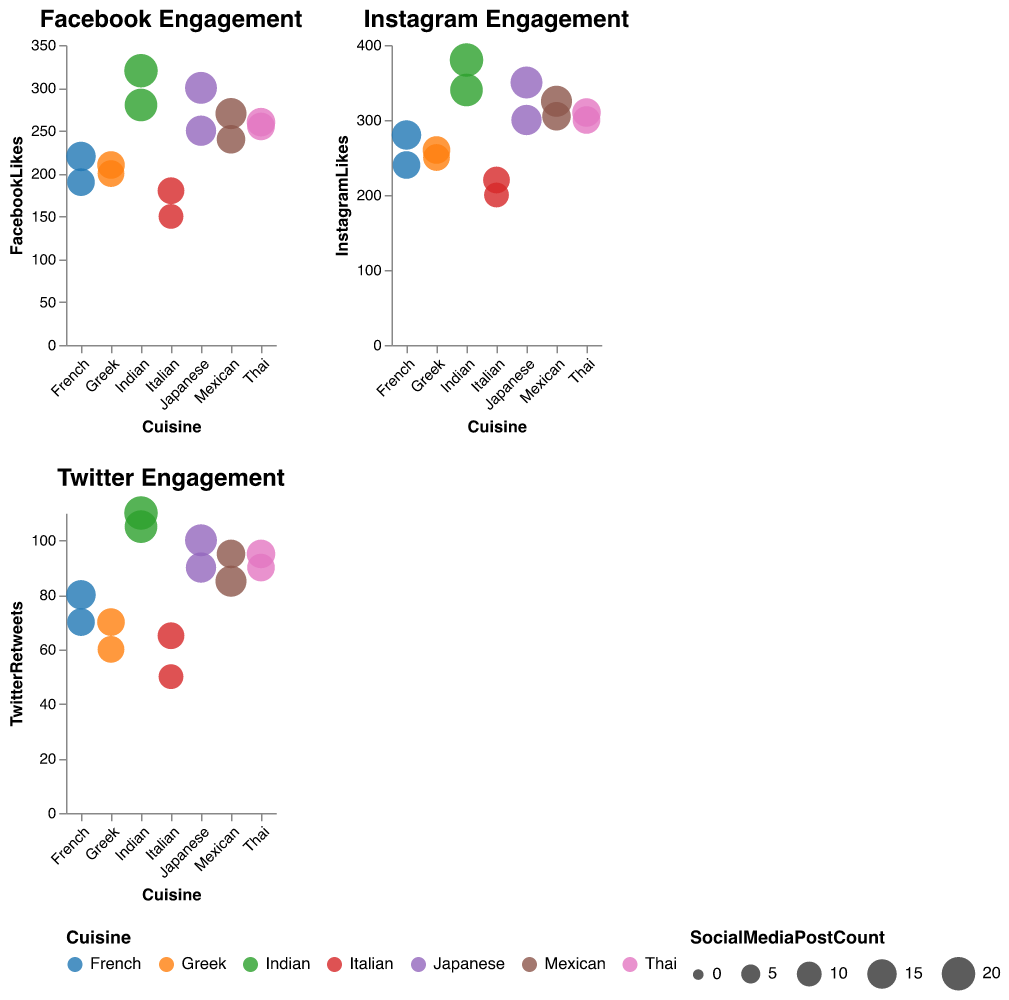What cuisine has the highest Facebook likes? The bubble chart titled "Facebook Engagement" shows that the Indian cuisine during the Spice Festival event has the highest Facebook likes at 320.
Answer: Indian How many Instagram likes did the Greek cuisine receive for the Island Hopping event? In the "Instagram Engagement" bubble chart, Greek cuisine's Island Hopping event shows 260 Instagram likes.
Answer: 260 Which cuisine and event theme combination had the greatest Twitter engagement? The bubble chart titled "Twitter Engagement" indicates that the Indian cuisine for the Spice Festival event had the highest Twitter retweets with 110.
Answer: Indian, Spice Festival What is the total Facebook likes for the Thai cuisine? Thai cuisine is listed twice in the "Facebook Engagement" chart with 260 and 255 Facebook likes. Adding these gives a total of 515.
Answer: 515 Which event theme for Italian cuisine received more Facebook likes, Wine Tasting or Family Dinner? Comparing Wine Tasting and Family Dinner event themes under Italian cuisine in "Facebook Engagement," Family Dinner had more Facebook likes with 180 compared to Wine Tasting's 150.
Answer: Family Dinner How does the Instagram engagement for the Mexican cuisine's Street Food Fiesta compare to the Day of the Dead? The "Instagram Engagement" chart shows that the Street Food Fiesta had 325 Instagram likes, while the Day of the Dead had 305 Instagram likes, making Street Food Fiesta higher by 20 likes.
Answer: Street Food Fiesta What is the total number of social media posts for French cuisine across all event themes? French cuisine has two events: Romantic Night (15 posts) and Bistro Experience (13 posts). Summing these gives a total of 28 posts.
Answer: 28 For Indian cuisine, which event theme had more Facebook likes, Spice Festival or Bollywood Night? In the "Facebook Engagement" chart, Spice Festival had 320 Facebook likes, and Bollywood Night had 280, so Spice Festival had more Facebook likes.
Answer: Spice Festival Which cuisine type showed the smallest bubble in the Twitter Engagement chart? The "Twitter Engagement" chart shows that the smallest bubble corresponds to Italian cuisine during the Wine Tasting event with 50 retweets and the smallest number of social media posts (10).
Answer: Italian, Wine Tasting What was the average number of Instagram likes for Japanese cuisine events? The "Instagram Engagement" chart shows Japanese cuisine had 350 likes for Sushi Workshop and 300 likes for Tea Ceremony. The average is (350 + 300)/2 = 325 likes.
Answer: 325 